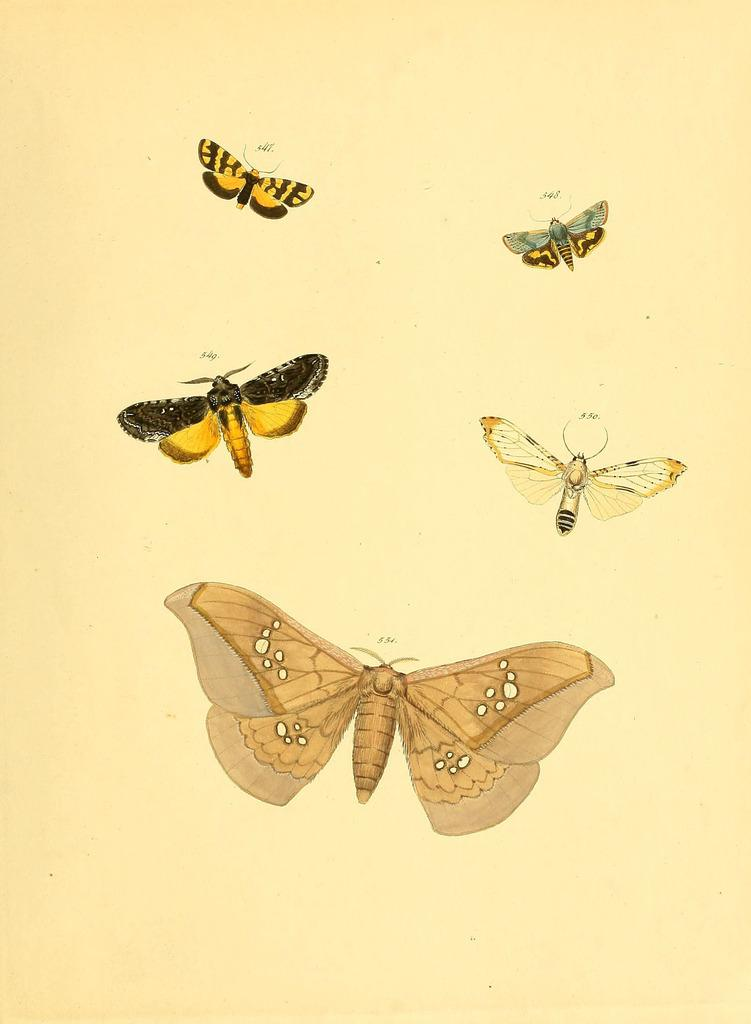What type of animals are depicted in the images in the picture? There are images of butterflies in the picture. What type of root can be seen growing in the image? There is no root present in the image; it features images of butterflies. How many kettles are visible in the image? There are no kettles visible in the image; it features images of butterflies. 